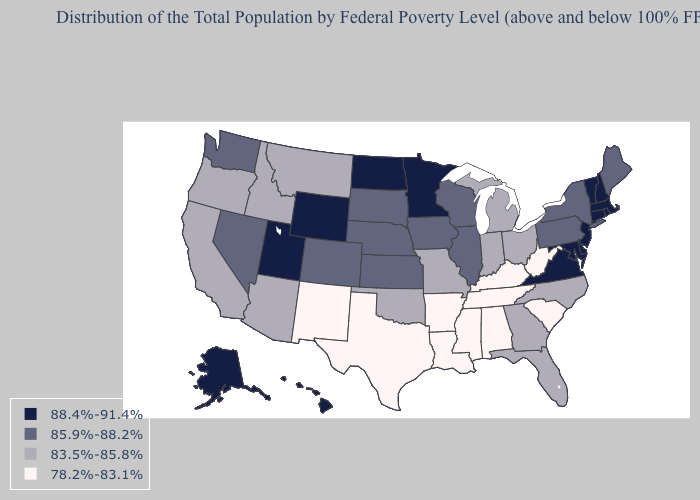Which states have the highest value in the USA?
Keep it brief. Alaska, Connecticut, Delaware, Hawaii, Maryland, Massachusetts, Minnesota, New Hampshire, New Jersey, North Dakota, Rhode Island, Utah, Vermont, Virginia, Wyoming. Does Arkansas have the lowest value in the South?
Concise answer only. Yes. Does New York have a lower value than Illinois?
Answer briefly. No. Which states have the highest value in the USA?
Answer briefly. Alaska, Connecticut, Delaware, Hawaii, Maryland, Massachusetts, Minnesota, New Hampshire, New Jersey, North Dakota, Rhode Island, Utah, Vermont, Virginia, Wyoming. Name the states that have a value in the range 83.5%-85.8%?
Give a very brief answer. Arizona, California, Florida, Georgia, Idaho, Indiana, Michigan, Missouri, Montana, North Carolina, Ohio, Oklahoma, Oregon. What is the lowest value in the USA?
Answer briefly. 78.2%-83.1%. What is the lowest value in the USA?
Write a very short answer. 78.2%-83.1%. Name the states that have a value in the range 85.9%-88.2%?
Keep it brief. Colorado, Illinois, Iowa, Kansas, Maine, Nebraska, Nevada, New York, Pennsylvania, South Dakota, Washington, Wisconsin. Does Virginia have the highest value in the South?
Keep it brief. Yes. Name the states that have a value in the range 88.4%-91.4%?
Keep it brief. Alaska, Connecticut, Delaware, Hawaii, Maryland, Massachusetts, Minnesota, New Hampshire, New Jersey, North Dakota, Rhode Island, Utah, Vermont, Virginia, Wyoming. Does the first symbol in the legend represent the smallest category?
Give a very brief answer. No. Does Massachusetts have the highest value in the USA?
Give a very brief answer. Yes. Does Hawaii have the highest value in the West?
Keep it brief. Yes. Among the states that border Illinois , which have the highest value?
Keep it brief. Iowa, Wisconsin. Name the states that have a value in the range 83.5%-85.8%?
Answer briefly. Arizona, California, Florida, Georgia, Idaho, Indiana, Michigan, Missouri, Montana, North Carolina, Ohio, Oklahoma, Oregon. 